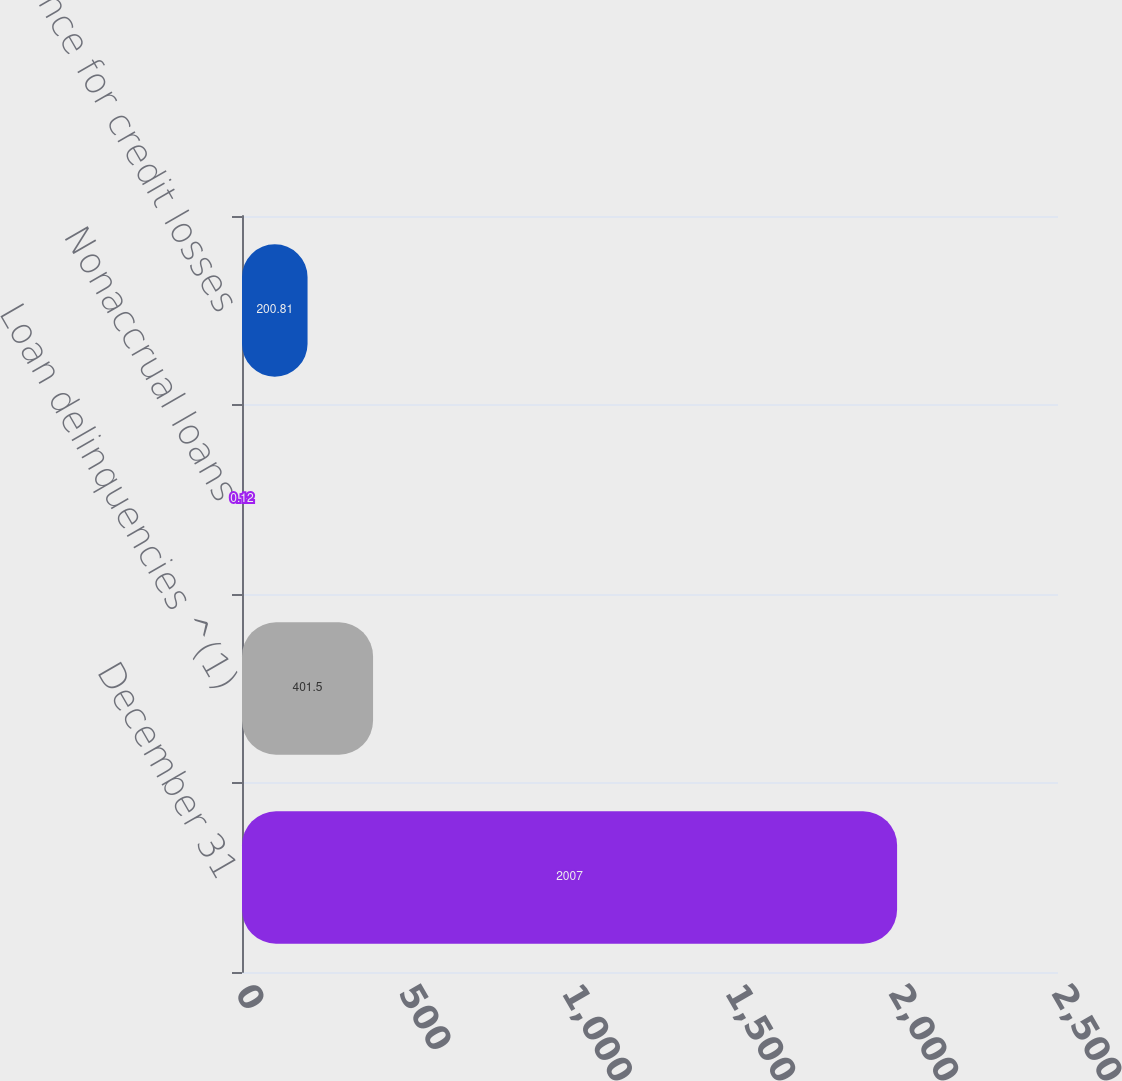Convert chart to OTSL. <chart><loc_0><loc_0><loc_500><loc_500><bar_chart><fcel>December 31<fcel>Loan delinquencies ^(1)<fcel>Nonaccrual loans<fcel>Allowance for credit losses<nl><fcel>2007<fcel>401.5<fcel>0.12<fcel>200.81<nl></chart> 